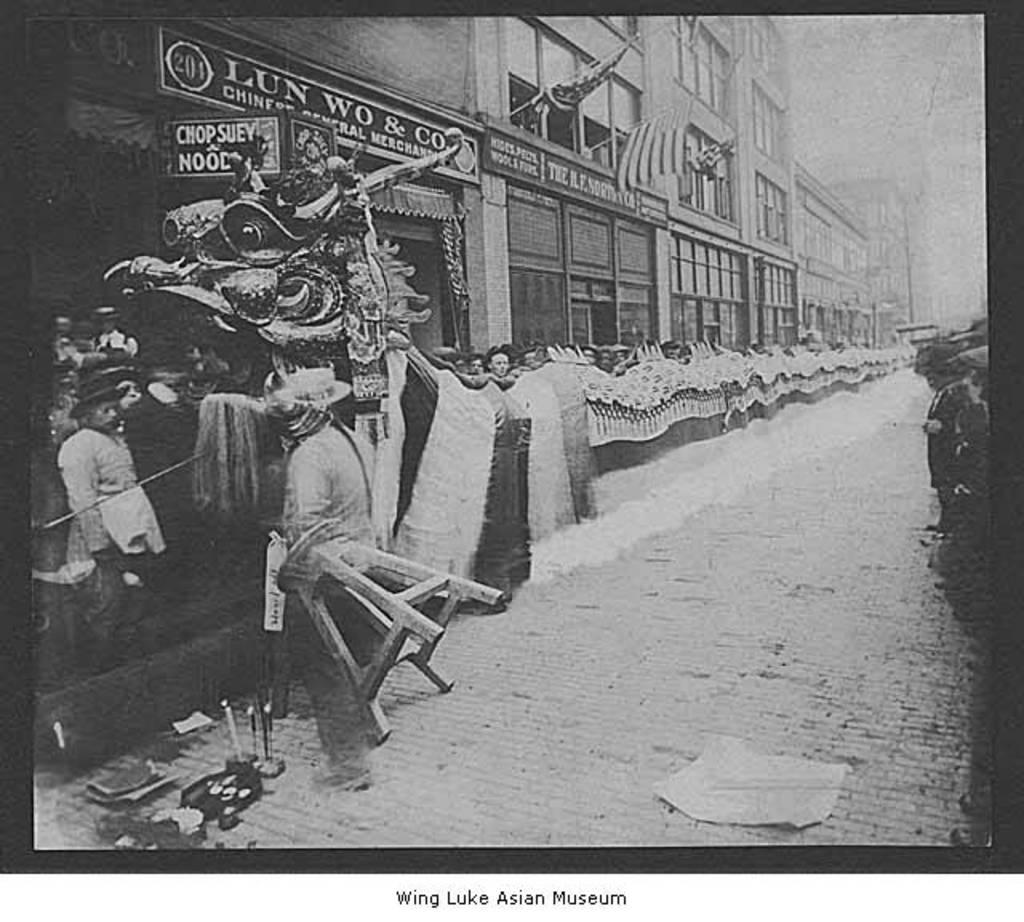What is the color scheme of the image? The image is black and white. What can be seen beside the road in the image? There are many people beside the road in the image. What type of structure is present in the image? There is a dragon-like structure in the image. What is visible in the background of the image? There are buildings in the background of the image. What type of scarf is being worn by the dragon in the image? There is no dragon wearing a scarf in the image, as the dragon-like structure is not a living creature. 